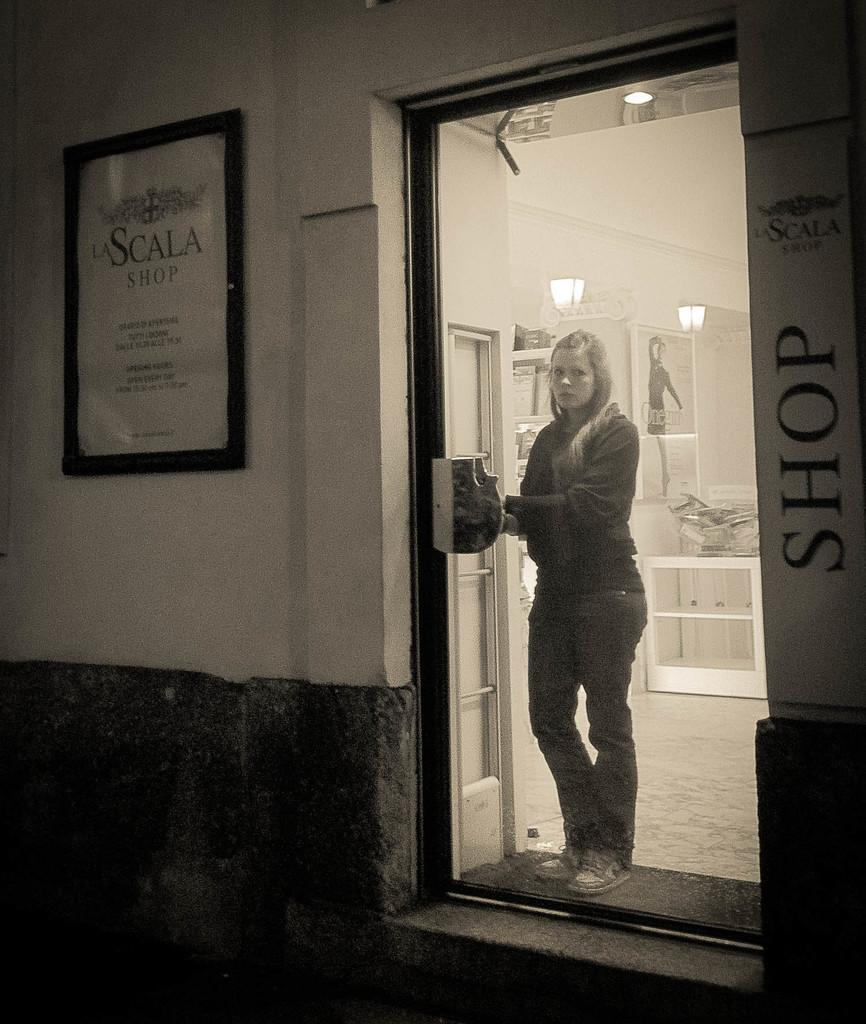Who or what is present in the image? There is a person in the image. What is the person wearing? The person is wearing clothes. Where is the person standing in relation to the door? The person is standing in front of a door. What can be seen on the wall in the image? There is a frame on the wall in the image. What type of jam is being spread on the pigs in the image? There are no pigs or jam present in the image. 